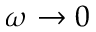Convert formula to latex. <formula><loc_0><loc_0><loc_500><loc_500>\omega \rightarrow 0</formula> 